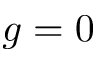Convert formula to latex. <formula><loc_0><loc_0><loc_500><loc_500>g = 0</formula> 